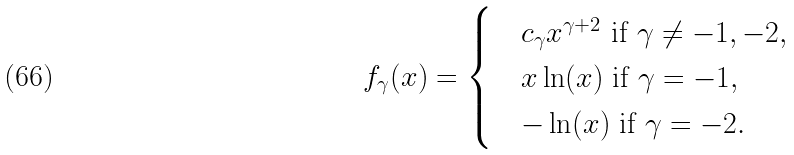Convert formula to latex. <formula><loc_0><loc_0><loc_500><loc_500>f _ { \gamma } ( x ) = \begin{cases} & c _ { \gamma } x ^ { \gamma + 2 } \text { if } \gamma \neq - 1 , - 2 , \\ & x \ln ( x ) \text { if } \gamma = - 1 , \\ & - \ln ( x ) \text { if } \gamma = - 2 . \end{cases}</formula> 